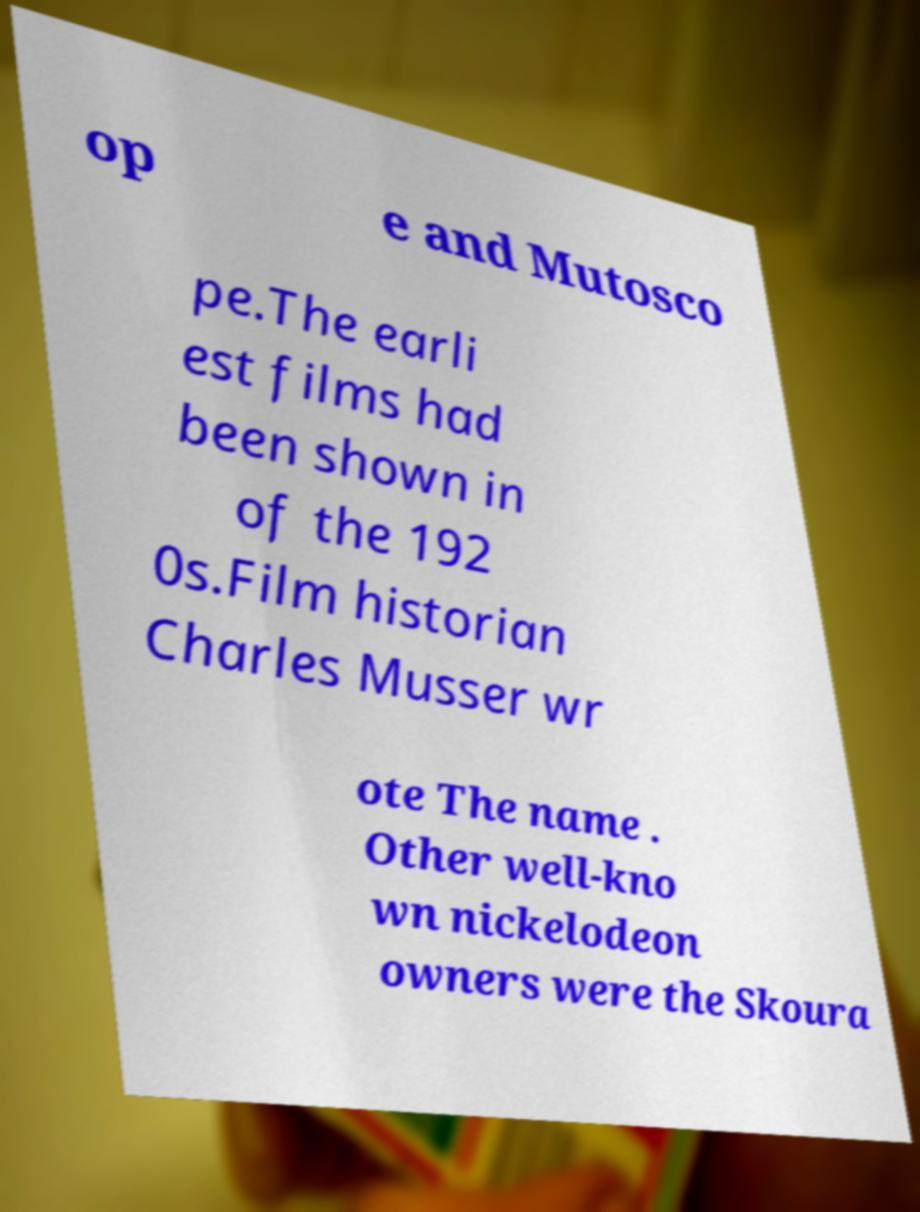Can you accurately transcribe the text from the provided image for me? op e and Mutosco pe.The earli est films had been shown in of the 192 0s.Film historian Charles Musser wr ote The name . Other well-kno wn nickelodeon owners were the Skoura 